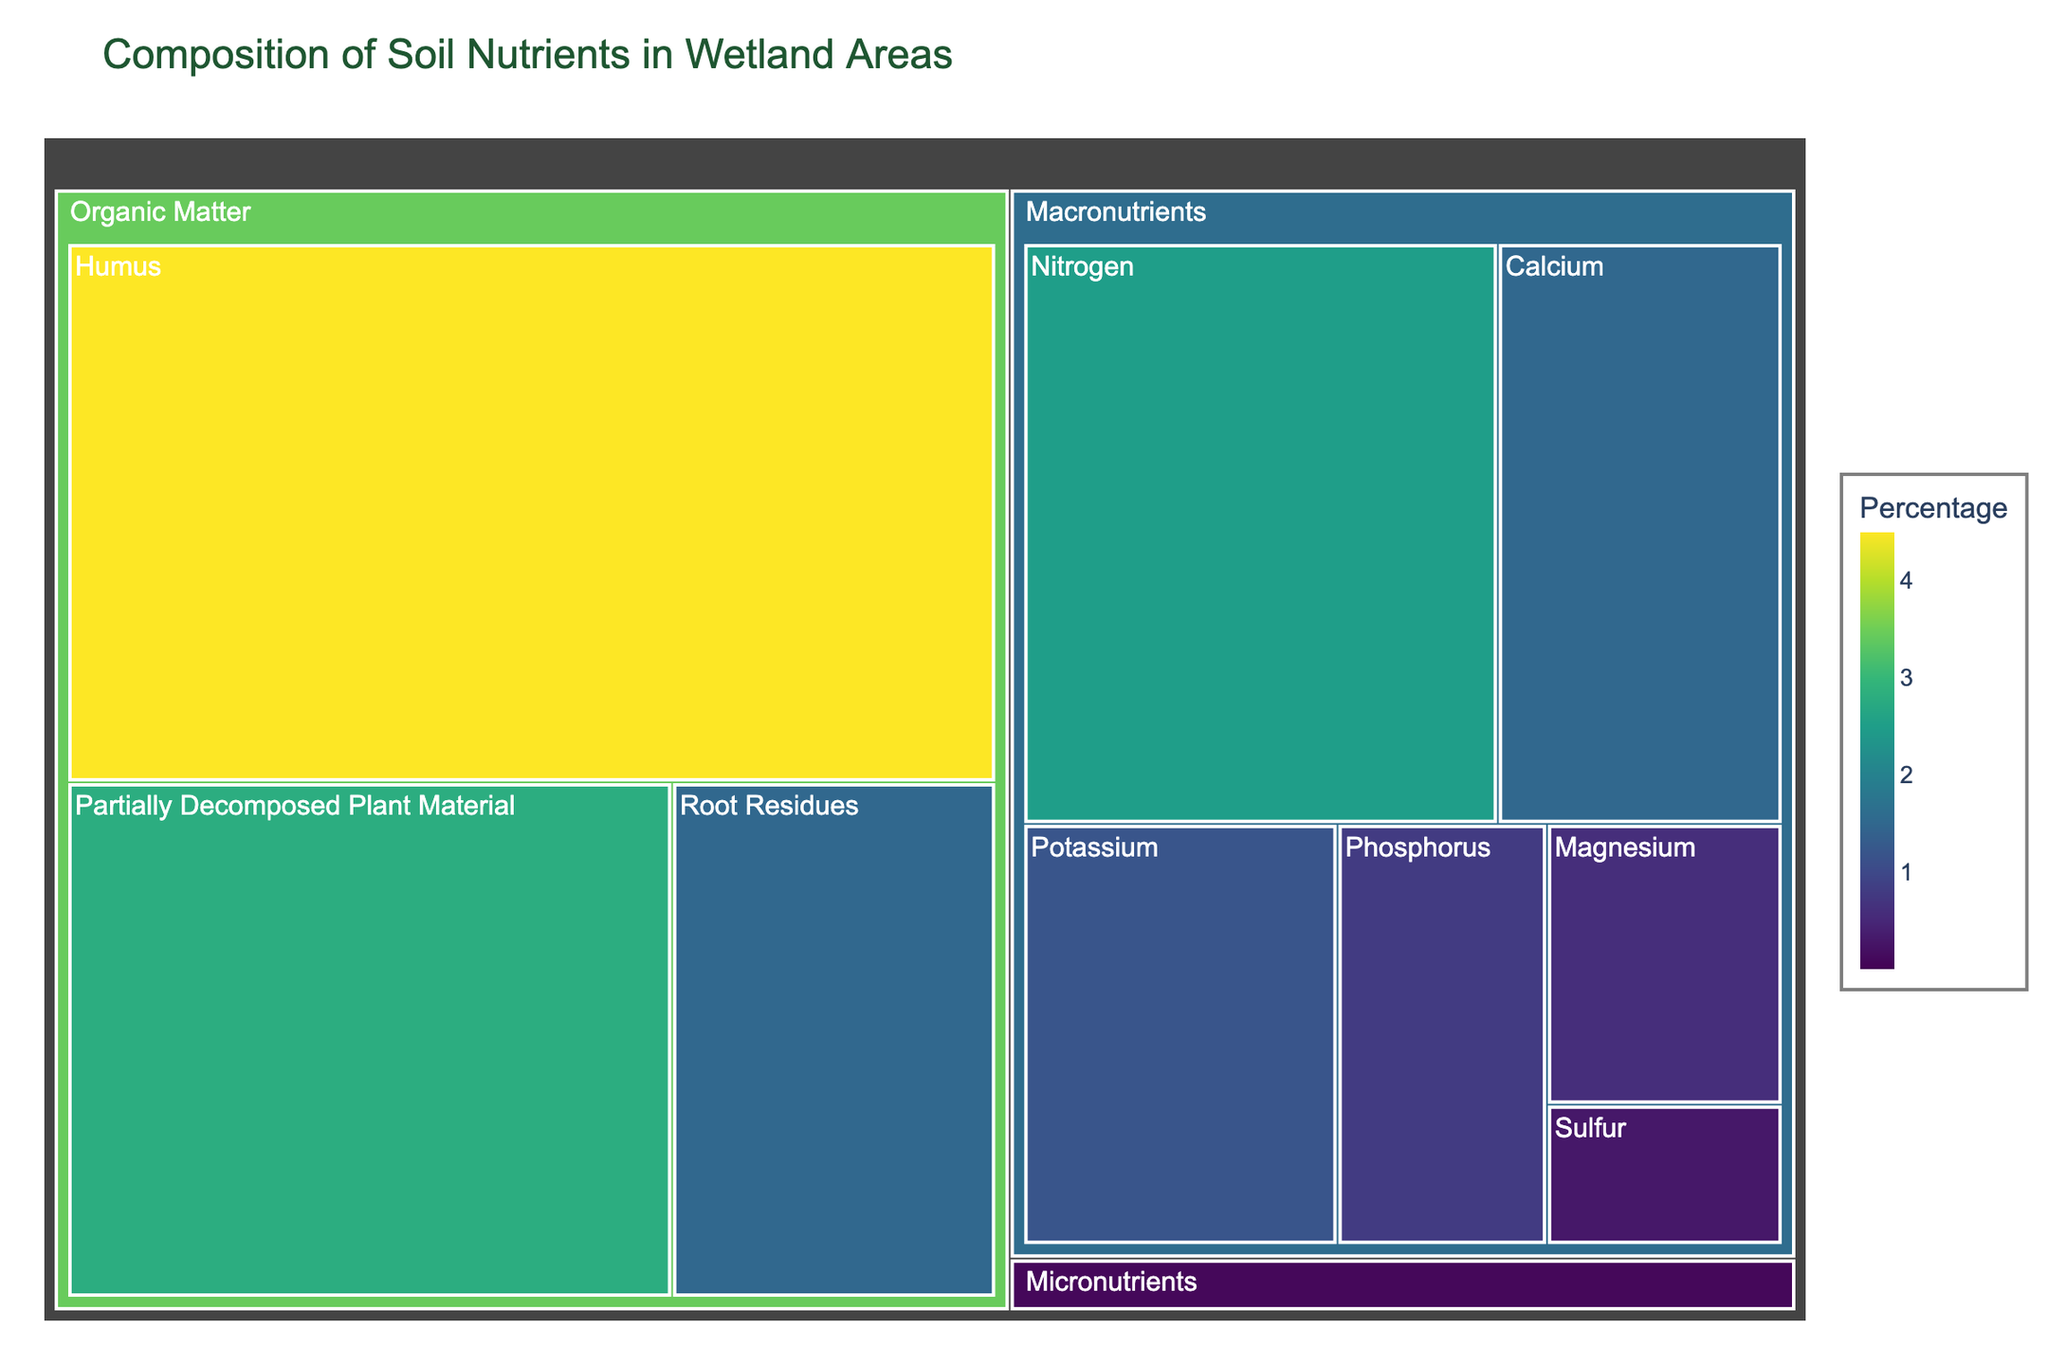what is the percentage of Humus? In the treemap, look for Humus under the Organic Matter category, where the percentage is written directly.
Answer: 4.5% Which category has the highest overall percentage? Sum the percentages of nutrients in each category: Macronutrients, Micronutrients, and Organic Matter. Organic Matter has 4.5 + 2.8 + 1.5 = 8.8%, which is higher than the totals for Macronutrients and Micronutrients.
Answer: Organic Matter How does the percentage of Nitrogen compare to Phosphorus? Look at the percentages for Nitrogen and Phosphorus under Macronutrients. Nitrogen has 2.5%, and Phosphorus has 0.8%, so Nitrogen is higher.
Answer: Nitrogen is higher What is the combined percentage of all Macronutrients? Add the percentages of all nutrients in the Macronutrients category: 2.5 + 0.8 + 1.2 + 1.5 + 0.6 + 0.3 = 6.9%.
Answer: 6.9% Which nutrient has the lowest percentage, and which category is it in? Identify the nutrient with the smallest percentage, which is 0.01% for Molybdenum under Micronutrients.
Answer: Molybdenum, Micronutrients What is the average percentage of Micronutrients? Add the percentages of Micronutrients and divide by the number of Micronutrients: (0.15 + 0.08 + 0.05 + 0.03 + 0.02 + 0.01) / 6 = 0.0567.
Answer: 0.0567% Which type of nutrient (Macro or Micro) has a greater individual nutrient with more than 1%? Observe the presence of nutrient elements in Macronutrients and Micronutrients categories with more than 1%. Macronutrients have several, while Micronutrients have none above 1%.
Answer: Macronutrients What's the percentage difference between the highest and lowest micronutrient? Highest Micronutrient percentage (Iron, 0.15%) minus lowest (Molybdenum, 0.01%) equals 0.14%.
Answer: 0.14% How does the total percentage of Macronutrients compare to that of Organic Matter? Sum the percentages of Organic Matter (4.5 + 2.8 + 1.5 = 8.8%) and compare it to the total of Macronutrients (6.9%). Organic Matter has a higher total percentage.
Answer: Organic Matter is higher What is the most significant organic matter component? Identify the component with the highest percentage within Organic Matter. Humus has the highest percentage at 4.5%.
Answer: Humus 